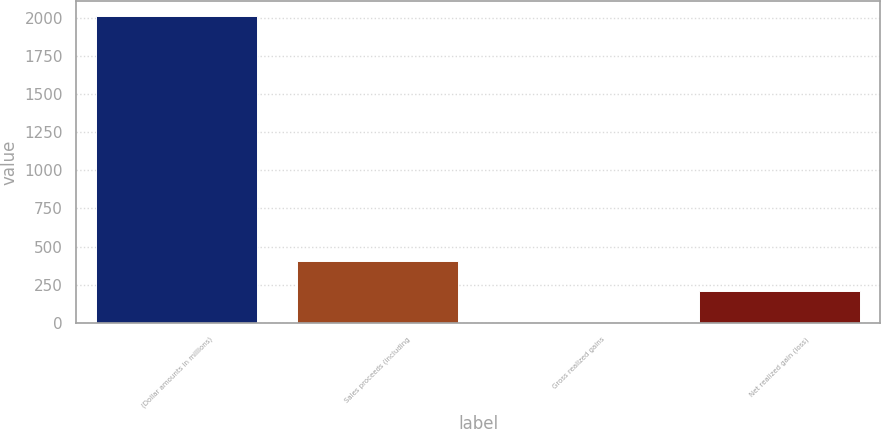Convert chart to OTSL. <chart><loc_0><loc_0><loc_500><loc_500><bar_chart><fcel>(Dollar amounts in millions)<fcel>Sales proceeds (including<fcel>Gross realized gains<fcel>Net realized gain (loss)<nl><fcel>2007<fcel>407.8<fcel>8<fcel>207.9<nl></chart> 